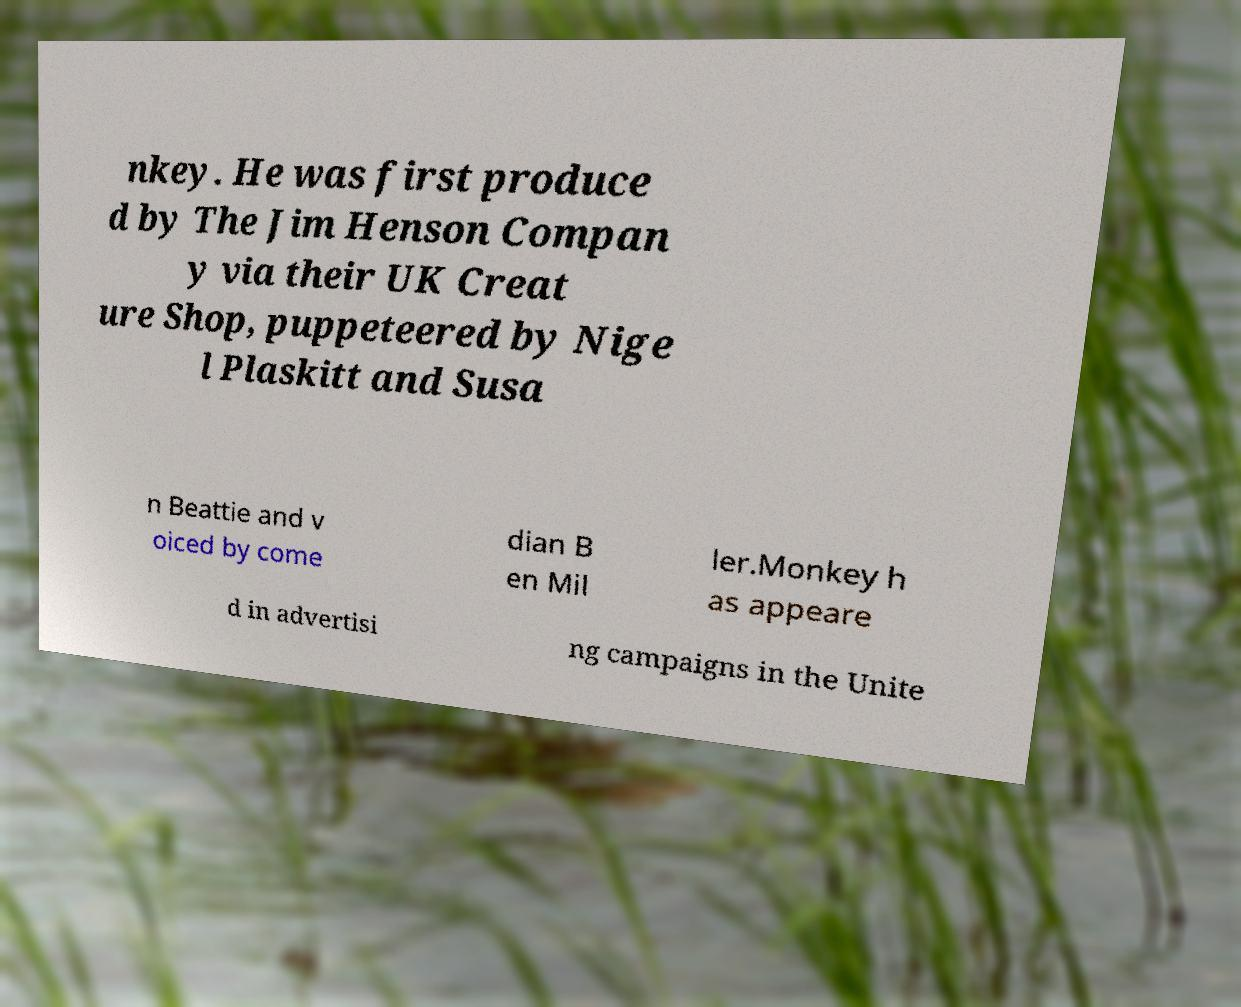Can you read and provide the text displayed in the image?This photo seems to have some interesting text. Can you extract and type it out for me? nkey. He was first produce d by The Jim Henson Compan y via their UK Creat ure Shop, puppeteered by Nige l Plaskitt and Susa n Beattie and v oiced by come dian B en Mil ler.Monkey h as appeare d in advertisi ng campaigns in the Unite 